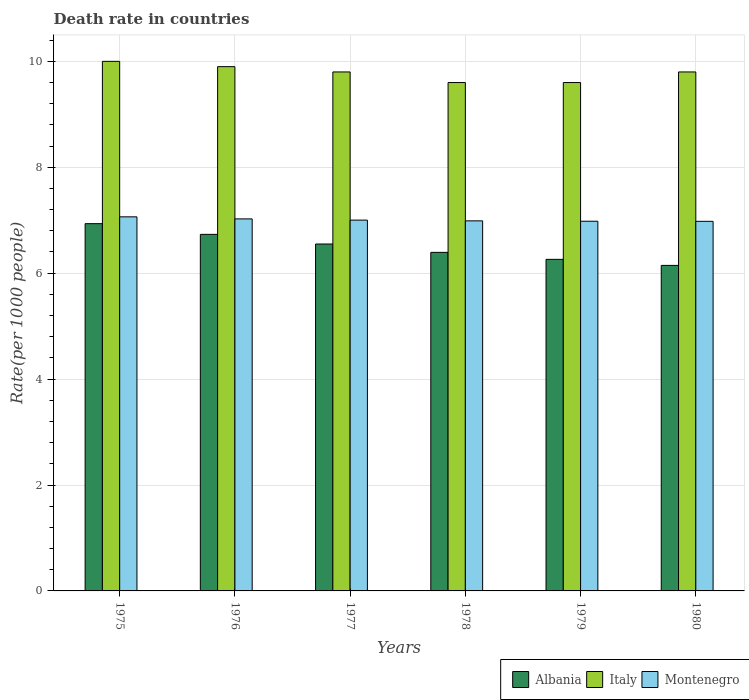How many different coloured bars are there?
Your response must be concise. 3. Are the number of bars on each tick of the X-axis equal?
Offer a very short reply. Yes. What is the label of the 4th group of bars from the left?
Offer a terse response. 1978. What is the death rate in Albania in 1978?
Provide a short and direct response. 6.39. Across all years, what is the maximum death rate in Montenegro?
Give a very brief answer. 7.06. Across all years, what is the minimum death rate in Montenegro?
Your response must be concise. 6.98. In which year was the death rate in Albania maximum?
Make the answer very short. 1975. In which year was the death rate in Italy minimum?
Provide a short and direct response. 1978. What is the total death rate in Albania in the graph?
Offer a very short reply. 39.02. What is the difference between the death rate in Albania in 1977 and that in 1980?
Make the answer very short. 0.4. What is the difference between the death rate in Montenegro in 1976 and the death rate in Italy in 1980?
Offer a terse response. -2.78. What is the average death rate in Albania per year?
Ensure brevity in your answer.  6.5. In the year 1976, what is the difference between the death rate in Albania and death rate in Montenegro?
Offer a very short reply. -0.29. In how many years, is the death rate in Italy greater than 7.6?
Provide a succinct answer. 6. What is the ratio of the death rate in Montenegro in 1977 to that in 1980?
Provide a short and direct response. 1. What is the difference between the highest and the second highest death rate in Italy?
Your answer should be compact. 0.1. What is the difference between the highest and the lowest death rate in Albania?
Ensure brevity in your answer.  0.79. In how many years, is the death rate in Italy greater than the average death rate in Italy taken over all years?
Ensure brevity in your answer.  4. What does the 1st bar from the right in 1980 represents?
Keep it short and to the point. Montenegro. Is it the case that in every year, the sum of the death rate in Italy and death rate in Montenegro is greater than the death rate in Albania?
Provide a succinct answer. Yes. How many bars are there?
Keep it short and to the point. 18. Are all the bars in the graph horizontal?
Make the answer very short. No. How many years are there in the graph?
Keep it short and to the point. 6. What is the difference between two consecutive major ticks on the Y-axis?
Offer a terse response. 2. Does the graph contain any zero values?
Your response must be concise. No. Does the graph contain grids?
Offer a terse response. Yes. How are the legend labels stacked?
Ensure brevity in your answer.  Horizontal. What is the title of the graph?
Your answer should be compact. Death rate in countries. Does "Cayman Islands" appear as one of the legend labels in the graph?
Provide a short and direct response. No. What is the label or title of the X-axis?
Your answer should be compact. Years. What is the label or title of the Y-axis?
Your answer should be very brief. Rate(per 1000 people). What is the Rate(per 1000 people) of Albania in 1975?
Offer a very short reply. 6.93. What is the Rate(per 1000 people) of Montenegro in 1975?
Keep it short and to the point. 7.06. What is the Rate(per 1000 people) of Albania in 1976?
Ensure brevity in your answer.  6.73. What is the Rate(per 1000 people) in Italy in 1976?
Your answer should be very brief. 9.9. What is the Rate(per 1000 people) of Montenegro in 1976?
Provide a short and direct response. 7.03. What is the Rate(per 1000 people) in Albania in 1977?
Your answer should be very brief. 6.55. What is the Rate(per 1000 people) in Italy in 1977?
Your answer should be compact. 9.8. What is the Rate(per 1000 people) of Montenegro in 1977?
Offer a very short reply. 7. What is the Rate(per 1000 people) in Albania in 1978?
Your response must be concise. 6.39. What is the Rate(per 1000 people) of Montenegro in 1978?
Offer a terse response. 6.99. What is the Rate(per 1000 people) in Albania in 1979?
Make the answer very short. 6.26. What is the Rate(per 1000 people) of Italy in 1979?
Your answer should be very brief. 9.6. What is the Rate(per 1000 people) in Montenegro in 1979?
Your answer should be compact. 6.98. What is the Rate(per 1000 people) in Albania in 1980?
Keep it short and to the point. 6.15. What is the Rate(per 1000 people) of Montenegro in 1980?
Offer a very short reply. 6.98. Across all years, what is the maximum Rate(per 1000 people) of Albania?
Offer a very short reply. 6.93. Across all years, what is the maximum Rate(per 1000 people) in Montenegro?
Provide a succinct answer. 7.06. Across all years, what is the minimum Rate(per 1000 people) in Albania?
Keep it short and to the point. 6.15. Across all years, what is the minimum Rate(per 1000 people) of Italy?
Make the answer very short. 9.6. Across all years, what is the minimum Rate(per 1000 people) in Montenegro?
Make the answer very short. 6.98. What is the total Rate(per 1000 people) in Albania in the graph?
Provide a short and direct response. 39.02. What is the total Rate(per 1000 people) in Italy in the graph?
Your answer should be very brief. 58.7. What is the total Rate(per 1000 people) in Montenegro in the graph?
Your response must be concise. 42.04. What is the difference between the Rate(per 1000 people) in Albania in 1975 and that in 1976?
Ensure brevity in your answer.  0.2. What is the difference between the Rate(per 1000 people) of Montenegro in 1975 and that in 1976?
Your response must be concise. 0.04. What is the difference between the Rate(per 1000 people) in Albania in 1975 and that in 1977?
Ensure brevity in your answer.  0.38. What is the difference between the Rate(per 1000 people) in Italy in 1975 and that in 1977?
Ensure brevity in your answer.  0.2. What is the difference between the Rate(per 1000 people) in Montenegro in 1975 and that in 1977?
Make the answer very short. 0.06. What is the difference between the Rate(per 1000 people) in Albania in 1975 and that in 1978?
Make the answer very short. 0.54. What is the difference between the Rate(per 1000 people) in Montenegro in 1975 and that in 1978?
Offer a terse response. 0.08. What is the difference between the Rate(per 1000 people) of Albania in 1975 and that in 1979?
Provide a succinct answer. 0.67. What is the difference between the Rate(per 1000 people) of Montenegro in 1975 and that in 1979?
Make the answer very short. 0.08. What is the difference between the Rate(per 1000 people) in Albania in 1975 and that in 1980?
Your response must be concise. 0.79. What is the difference between the Rate(per 1000 people) in Montenegro in 1975 and that in 1980?
Keep it short and to the point. 0.09. What is the difference between the Rate(per 1000 people) of Albania in 1976 and that in 1977?
Provide a short and direct response. 0.18. What is the difference between the Rate(per 1000 people) in Italy in 1976 and that in 1977?
Offer a terse response. 0.1. What is the difference between the Rate(per 1000 people) in Montenegro in 1976 and that in 1977?
Make the answer very short. 0.02. What is the difference between the Rate(per 1000 people) in Albania in 1976 and that in 1978?
Give a very brief answer. 0.34. What is the difference between the Rate(per 1000 people) in Italy in 1976 and that in 1978?
Provide a succinct answer. 0.3. What is the difference between the Rate(per 1000 people) in Montenegro in 1976 and that in 1978?
Provide a succinct answer. 0.04. What is the difference between the Rate(per 1000 people) of Albania in 1976 and that in 1979?
Offer a terse response. 0.47. What is the difference between the Rate(per 1000 people) in Italy in 1976 and that in 1979?
Make the answer very short. 0.3. What is the difference between the Rate(per 1000 people) of Montenegro in 1976 and that in 1979?
Your answer should be very brief. 0.04. What is the difference between the Rate(per 1000 people) in Albania in 1976 and that in 1980?
Make the answer very short. 0.59. What is the difference between the Rate(per 1000 people) of Italy in 1976 and that in 1980?
Provide a succinct answer. 0.1. What is the difference between the Rate(per 1000 people) of Montenegro in 1976 and that in 1980?
Keep it short and to the point. 0.05. What is the difference between the Rate(per 1000 people) of Albania in 1977 and that in 1978?
Ensure brevity in your answer.  0.16. What is the difference between the Rate(per 1000 people) of Montenegro in 1977 and that in 1978?
Ensure brevity in your answer.  0.01. What is the difference between the Rate(per 1000 people) in Albania in 1977 and that in 1979?
Your answer should be compact. 0.29. What is the difference between the Rate(per 1000 people) of Italy in 1977 and that in 1979?
Offer a very short reply. 0.2. What is the difference between the Rate(per 1000 people) in Montenegro in 1977 and that in 1979?
Your response must be concise. 0.02. What is the difference between the Rate(per 1000 people) of Albania in 1977 and that in 1980?
Your response must be concise. 0.4. What is the difference between the Rate(per 1000 people) of Italy in 1977 and that in 1980?
Provide a short and direct response. 0. What is the difference between the Rate(per 1000 people) in Montenegro in 1977 and that in 1980?
Provide a short and direct response. 0.02. What is the difference between the Rate(per 1000 people) in Albania in 1978 and that in 1979?
Offer a terse response. 0.13. What is the difference between the Rate(per 1000 people) of Montenegro in 1978 and that in 1979?
Your response must be concise. 0.01. What is the difference between the Rate(per 1000 people) in Albania in 1978 and that in 1980?
Your answer should be very brief. 0.25. What is the difference between the Rate(per 1000 people) of Montenegro in 1978 and that in 1980?
Offer a very short reply. 0.01. What is the difference between the Rate(per 1000 people) in Albania in 1979 and that in 1980?
Your answer should be compact. 0.11. What is the difference between the Rate(per 1000 people) of Montenegro in 1979 and that in 1980?
Your answer should be compact. 0. What is the difference between the Rate(per 1000 people) of Albania in 1975 and the Rate(per 1000 people) of Italy in 1976?
Ensure brevity in your answer.  -2.96. What is the difference between the Rate(per 1000 people) in Albania in 1975 and the Rate(per 1000 people) in Montenegro in 1976?
Ensure brevity in your answer.  -0.09. What is the difference between the Rate(per 1000 people) in Italy in 1975 and the Rate(per 1000 people) in Montenegro in 1976?
Provide a short and direct response. 2.98. What is the difference between the Rate(per 1000 people) in Albania in 1975 and the Rate(per 1000 people) in Italy in 1977?
Offer a very short reply. -2.87. What is the difference between the Rate(per 1000 people) in Albania in 1975 and the Rate(per 1000 people) in Montenegro in 1977?
Offer a terse response. -0.07. What is the difference between the Rate(per 1000 people) in Italy in 1975 and the Rate(per 1000 people) in Montenegro in 1977?
Offer a very short reply. 3. What is the difference between the Rate(per 1000 people) in Albania in 1975 and the Rate(per 1000 people) in Italy in 1978?
Offer a terse response. -2.67. What is the difference between the Rate(per 1000 people) of Albania in 1975 and the Rate(per 1000 people) of Montenegro in 1978?
Keep it short and to the point. -0.05. What is the difference between the Rate(per 1000 people) in Italy in 1975 and the Rate(per 1000 people) in Montenegro in 1978?
Provide a short and direct response. 3.01. What is the difference between the Rate(per 1000 people) in Albania in 1975 and the Rate(per 1000 people) in Italy in 1979?
Keep it short and to the point. -2.67. What is the difference between the Rate(per 1000 people) of Albania in 1975 and the Rate(per 1000 people) of Montenegro in 1979?
Make the answer very short. -0.05. What is the difference between the Rate(per 1000 people) of Italy in 1975 and the Rate(per 1000 people) of Montenegro in 1979?
Provide a succinct answer. 3.02. What is the difference between the Rate(per 1000 people) in Albania in 1975 and the Rate(per 1000 people) in Italy in 1980?
Provide a short and direct response. -2.87. What is the difference between the Rate(per 1000 people) in Albania in 1975 and the Rate(per 1000 people) in Montenegro in 1980?
Keep it short and to the point. -0.04. What is the difference between the Rate(per 1000 people) in Italy in 1975 and the Rate(per 1000 people) in Montenegro in 1980?
Your answer should be very brief. 3.02. What is the difference between the Rate(per 1000 people) in Albania in 1976 and the Rate(per 1000 people) in Italy in 1977?
Ensure brevity in your answer.  -3.07. What is the difference between the Rate(per 1000 people) of Albania in 1976 and the Rate(per 1000 people) of Montenegro in 1977?
Ensure brevity in your answer.  -0.27. What is the difference between the Rate(per 1000 people) in Italy in 1976 and the Rate(per 1000 people) in Montenegro in 1977?
Your answer should be compact. 2.9. What is the difference between the Rate(per 1000 people) of Albania in 1976 and the Rate(per 1000 people) of Italy in 1978?
Make the answer very short. -2.87. What is the difference between the Rate(per 1000 people) in Albania in 1976 and the Rate(per 1000 people) in Montenegro in 1978?
Provide a succinct answer. -0.26. What is the difference between the Rate(per 1000 people) of Italy in 1976 and the Rate(per 1000 people) of Montenegro in 1978?
Make the answer very short. 2.91. What is the difference between the Rate(per 1000 people) in Albania in 1976 and the Rate(per 1000 people) in Italy in 1979?
Ensure brevity in your answer.  -2.87. What is the difference between the Rate(per 1000 people) of Albania in 1976 and the Rate(per 1000 people) of Montenegro in 1979?
Make the answer very short. -0.25. What is the difference between the Rate(per 1000 people) of Italy in 1976 and the Rate(per 1000 people) of Montenegro in 1979?
Give a very brief answer. 2.92. What is the difference between the Rate(per 1000 people) of Albania in 1976 and the Rate(per 1000 people) of Italy in 1980?
Give a very brief answer. -3.07. What is the difference between the Rate(per 1000 people) of Albania in 1976 and the Rate(per 1000 people) of Montenegro in 1980?
Your answer should be compact. -0.25. What is the difference between the Rate(per 1000 people) in Italy in 1976 and the Rate(per 1000 people) in Montenegro in 1980?
Give a very brief answer. 2.92. What is the difference between the Rate(per 1000 people) of Albania in 1977 and the Rate(per 1000 people) of Italy in 1978?
Provide a short and direct response. -3.05. What is the difference between the Rate(per 1000 people) of Albania in 1977 and the Rate(per 1000 people) of Montenegro in 1978?
Make the answer very short. -0.44. What is the difference between the Rate(per 1000 people) in Italy in 1977 and the Rate(per 1000 people) in Montenegro in 1978?
Your answer should be very brief. 2.81. What is the difference between the Rate(per 1000 people) of Albania in 1977 and the Rate(per 1000 people) of Italy in 1979?
Ensure brevity in your answer.  -3.05. What is the difference between the Rate(per 1000 people) in Albania in 1977 and the Rate(per 1000 people) in Montenegro in 1979?
Keep it short and to the point. -0.43. What is the difference between the Rate(per 1000 people) in Italy in 1977 and the Rate(per 1000 people) in Montenegro in 1979?
Offer a very short reply. 2.82. What is the difference between the Rate(per 1000 people) in Albania in 1977 and the Rate(per 1000 people) in Italy in 1980?
Offer a terse response. -3.25. What is the difference between the Rate(per 1000 people) of Albania in 1977 and the Rate(per 1000 people) of Montenegro in 1980?
Your answer should be compact. -0.43. What is the difference between the Rate(per 1000 people) of Italy in 1977 and the Rate(per 1000 people) of Montenegro in 1980?
Keep it short and to the point. 2.82. What is the difference between the Rate(per 1000 people) of Albania in 1978 and the Rate(per 1000 people) of Italy in 1979?
Provide a succinct answer. -3.21. What is the difference between the Rate(per 1000 people) of Albania in 1978 and the Rate(per 1000 people) of Montenegro in 1979?
Offer a terse response. -0.59. What is the difference between the Rate(per 1000 people) of Italy in 1978 and the Rate(per 1000 people) of Montenegro in 1979?
Keep it short and to the point. 2.62. What is the difference between the Rate(per 1000 people) of Albania in 1978 and the Rate(per 1000 people) of Italy in 1980?
Keep it short and to the point. -3.41. What is the difference between the Rate(per 1000 people) of Albania in 1978 and the Rate(per 1000 people) of Montenegro in 1980?
Provide a short and direct response. -0.59. What is the difference between the Rate(per 1000 people) in Italy in 1978 and the Rate(per 1000 people) in Montenegro in 1980?
Provide a succinct answer. 2.62. What is the difference between the Rate(per 1000 people) in Albania in 1979 and the Rate(per 1000 people) in Italy in 1980?
Your response must be concise. -3.54. What is the difference between the Rate(per 1000 people) in Albania in 1979 and the Rate(per 1000 people) in Montenegro in 1980?
Keep it short and to the point. -0.72. What is the difference between the Rate(per 1000 people) of Italy in 1979 and the Rate(per 1000 people) of Montenegro in 1980?
Make the answer very short. 2.62. What is the average Rate(per 1000 people) of Albania per year?
Provide a succinct answer. 6.5. What is the average Rate(per 1000 people) in Italy per year?
Give a very brief answer. 9.78. What is the average Rate(per 1000 people) of Montenegro per year?
Provide a short and direct response. 7.01. In the year 1975, what is the difference between the Rate(per 1000 people) in Albania and Rate(per 1000 people) in Italy?
Provide a succinct answer. -3.06. In the year 1975, what is the difference between the Rate(per 1000 people) of Albania and Rate(per 1000 people) of Montenegro?
Provide a succinct answer. -0.13. In the year 1975, what is the difference between the Rate(per 1000 people) in Italy and Rate(per 1000 people) in Montenegro?
Give a very brief answer. 2.94. In the year 1976, what is the difference between the Rate(per 1000 people) in Albania and Rate(per 1000 people) in Italy?
Offer a terse response. -3.17. In the year 1976, what is the difference between the Rate(per 1000 people) of Albania and Rate(per 1000 people) of Montenegro?
Make the answer very short. -0.29. In the year 1976, what is the difference between the Rate(per 1000 people) of Italy and Rate(per 1000 people) of Montenegro?
Your answer should be very brief. 2.88. In the year 1977, what is the difference between the Rate(per 1000 people) in Albania and Rate(per 1000 people) in Italy?
Ensure brevity in your answer.  -3.25. In the year 1977, what is the difference between the Rate(per 1000 people) of Albania and Rate(per 1000 people) of Montenegro?
Offer a terse response. -0.45. In the year 1977, what is the difference between the Rate(per 1000 people) of Italy and Rate(per 1000 people) of Montenegro?
Keep it short and to the point. 2.8. In the year 1978, what is the difference between the Rate(per 1000 people) in Albania and Rate(per 1000 people) in Italy?
Make the answer very short. -3.21. In the year 1978, what is the difference between the Rate(per 1000 people) in Albania and Rate(per 1000 people) in Montenegro?
Offer a very short reply. -0.59. In the year 1978, what is the difference between the Rate(per 1000 people) of Italy and Rate(per 1000 people) of Montenegro?
Make the answer very short. 2.61. In the year 1979, what is the difference between the Rate(per 1000 people) in Albania and Rate(per 1000 people) in Italy?
Your answer should be compact. -3.34. In the year 1979, what is the difference between the Rate(per 1000 people) in Albania and Rate(per 1000 people) in Montenegro?
Provide a succinct answer. -0.72. In the year 1979, what is the difference between the Rate(per 1000 people) in Italy and Rate(per 1000 people) in Montenegro?
Offer a very short reply. 2.62. In the year 1980, what is the difference between the Rate(per 1000 people) of Albania and Rate(per 1000 people) of Italy?
Offer a terse response. -3.65. In the year 1980, what is the difference between the Rate(per 1000 people) of Albania and Rate(per 1000 people) of Montenegro?
Your response must be concise. -0.83. In the year 1980, what is the difference between the Rate(per 1000 people) of Italy and Rate(per 1000 people) of Montenegro?
Make the answer very short. 2.82. What is the ratio of the Rate(per 1000 people) of Albania in 1975 to that in 1976?
Offer a very short reply. 1.03. What is the ratio of the Rate(per 1000 people) of Montenegro in 1975 to that in 1976?
Offer a terse response. 1.01. What is the ratio of the Rate(per 1000 people) in Albania in 1975 to that in 1977?
Your answer should be compact. 1.06. What is the ratio of the Rate(per 1000 people) of Italy in 1975 to that in 1977?
Give a very brief answer. 1.02. What is the ratio of the Rate(per 1000 people) of Montenegro in 1975 to that in 1977?
Offer a terse response. 1.01. What is the ratio of the Rate(per 1000 people) in Albania in 1975 to that in 1978?
Offer a terse response. 1.08. What is the ratio of the Rate(per 1000 people) of Italy in 1975 to that in 1978?
Ensure brevity in your answer.  1.04. What is the ratio of the Rate(per 1000 people) of Montenegro in 1975 to that in 1978?
Your response must be concise. 1.01. What is the ratio of the Rate(per 1000 people) of Albania in 1975 to that in 1979?
Keep it short and to the point. 1.11. What is the ratio of the Rate(per 1000 people) in Italy in 1975 to that in 1979?
Make the answer very short. 1.04. What is the ratio of the Rate(per 1000 people) in Montenegro in 1975 to that in 1979?
Keep it short and to the point. 1.01. What is the ratio of the Rate(per 1000 people) in Albania in 1975 to that in 1980?
Provide a short and direct response. 1.13. What is the ratio of the Rate(per 1000 people) of Italy in 1975 to that in 1980?
Give a very brief answer. 1.02. What is the ratio of the Rate(per 1000 people) of Montenegro in 1975 to that in 1980?
Keep it short and to the point. 1.01. What is the ratio of the Rate(per 1000 people) in Albania in 1976 to that in 1977?
Make the answer very short. 1.03. What is the ratio of the Rate(per 1000 people) of Italy in 1976 to that in 1977?
Offer a terse response. 1.01. What is the ratio of the Rate(per 1000 people) in Montenegro in 1976 to that in 1977?
Your response must be concise. 1. What is the ratio of the Rate(per 1000 people) of Albania in 1976 to that in 1978?
Offer a terse response. 1.05. What is the ratio of the Rate(per 1000 people) of Italy in 1976 to that in 1978?
Your response must be concise. 1.03. What is the ratio of the Rate(per 1000 people) in Montenegro in 1976 to that in 1978?
Offer a very short reply. 1.01. What is the ratio of the Rate(per 1000 people) in Albania in 1976 to that in 1979?
Make the answer very short. 1.08. What is the ratio of the Rate(per 1000 people) of Italy in 1976 to that in 1979?
Your answer should be compact. 1.03. What is the ratio of the Rate(per 1000 people) of Albania in 1976 to that in 1980?
Ensure brevity in your answer.  1.1. What is the ratio of the Rate(per 1000 people) of Italy in 1976 to that in 1980?
Keep it short and to the point. 1.01. What is the ratio of the Rate(per 1000 people) in Montenegro in 1976 to that in 1980?
Keep it short and to the point. 1.01. What is the ratio of the Rate(per 1000 people) in Albania in 1977 to that in 1978?
Your response must be concise. 1.02. What is the ratio of the Rate(per 1000 people) of Italy in 1977 to that in 1978?
Your response must be concise. 1.02. What is the ratio of the Rate(per 1000 people) of Albania in 1977 to that in 1979?
Give a very brief answer. 1.05. What is the ratio of the Rate(per 1000 people) of Italy in 1977 to that in 1979?
Ensure brevity in your answer.  1.02. What is the ratio of the Rate(per 1000 people) in Albania in 1977 to that in 1980?
Your answer should be compact. 1.07. What is the ratio of the Rate(per 1000 people) in Albania in 1978 to that in 1979?
Provide a succinct answer. 1.02. What is the ratio of the Rate(per 1000 people) of Italy in 1978 to that in 1980?
Your answer should be compact. 0.98. What is the ratio of the Rate(per 1000 people) in Montenegro in 1978 to that in 1980?
Your answer should be compact. 1. What is the ratio of the Rate(per 1000 people) of Albania in 1979 to that in 1980?
Ensure brevity in your answer.  1.02. What is the ratio of the Rate(per 1000 people) in Italy in 1979 to that in 1980?
Your answer should be very brief. 0.98. What is the ratio of the Rate(per 1000 people) of Montenegro in 1979 to that in 1980?
Your answer should be very brief. 1. What is the difference between the highest and the second highest Rate(per 1000 people) of Albania?
Your answer should be very brief. 0.2. What is the difference between the highest and the second highest Rate(per 1000 people) of Montenegro?
Provide a short and direct response. 0.04. What is the difference between the highest and the lowest Rate(per 1000 people) in Albania?
Make the answer very short. 0.79. What is the difference between the highest and the lowest Rate(per 1000 people) of Italy?
Ensure brevity in your answer.  0.4. What is the difference between the highest and the lowest Rate(per 1000 people) in Montenegro?
Make the answer very short. 0.09. 